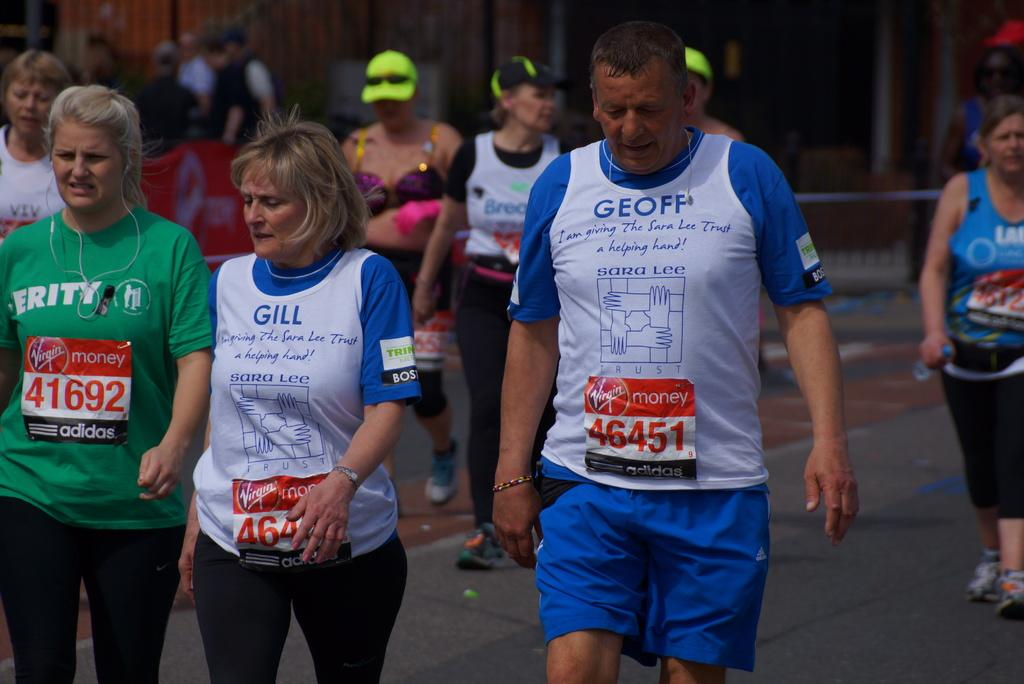Provide a one-sentence caption for the provided image. Participants in a marathon wearing Virgin Money number tags include #46451 and 41692. 